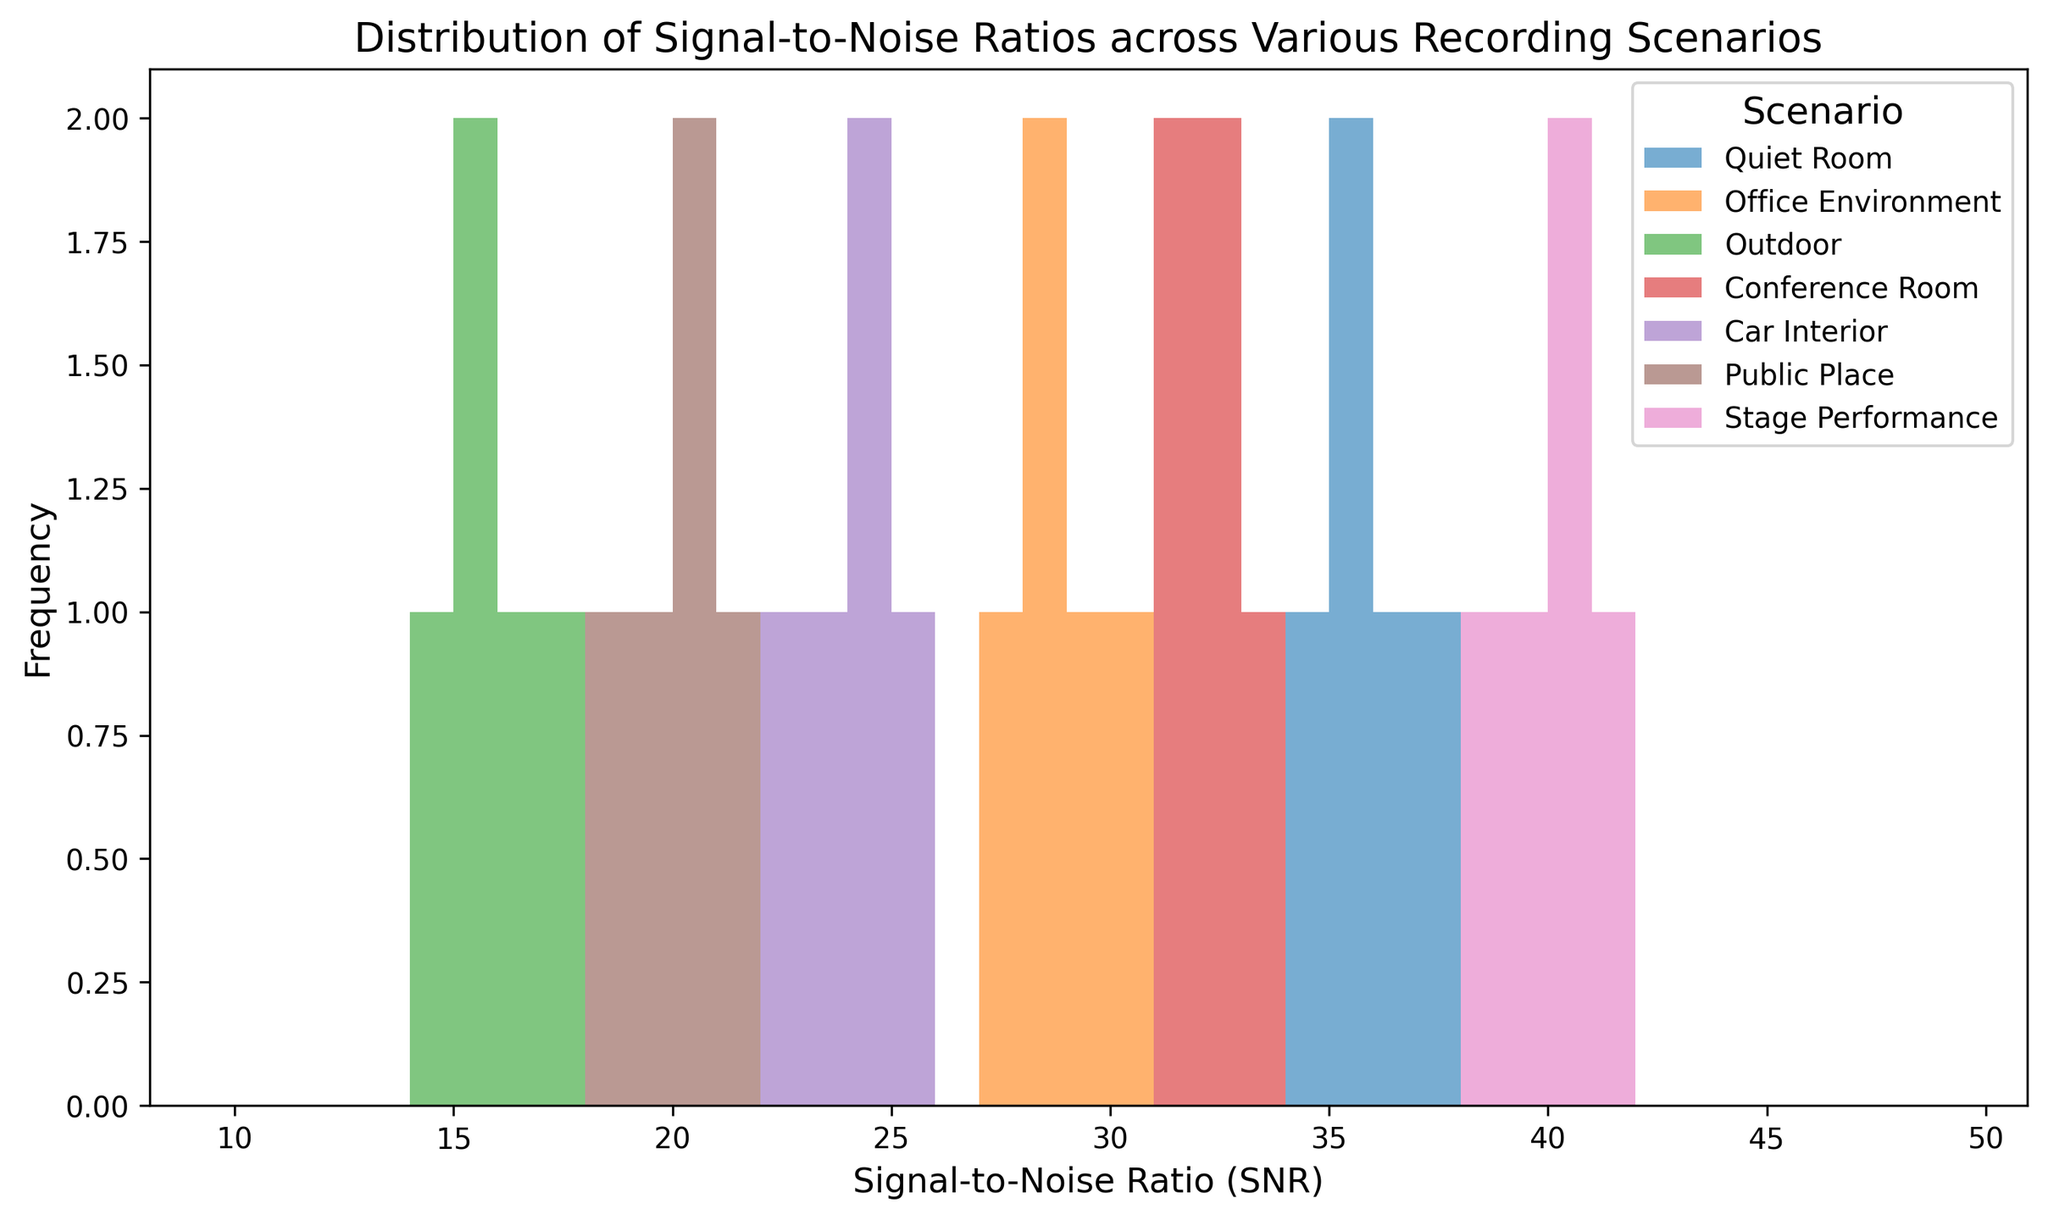What's the most frequent SNR range for stage performances? The most frequent SNR range for stage performances can be identified by locating the highest bar in the histogram's section corresponding to stage performances, which are typically shaded in pink. Look for which bin in the stage performance section has the highest count.
Answer: 40-41 Which scenario has the lowest SNR range, and what is that range? To find the scenario with the lowest SNR range, examine the bins on the far left of the histogram and identify which scenario's colors are present in this area. The lowest range corresponds to the `Outdoor` scenario, represented by bars in green.
Answer: Outdoor, 14-17 How do the SNR values for a quiet room compare to those in a conference room? To compare the SNR values, analyze the histogram sections for the quiet room (shaded in blue) and the conference room (shaded in red). Both sets of bars fall within a similar range, just over 30, but the quiet room's SNR values are generally a bit higher.
Answer: Quiet Room's SNR values are slightly higher What is the average SNR for an office environment and a car interior combined? Calculate the average SNR by summing the SNR values of both scenarios and dividing by the total number of data points. The office environment has SNRs of 28, 29, 27, 30, and 28. The car interior has SNRs of 24, 22, 23, 24, and 25. The combined sum is (28 + 29 + 27 + 30 + 28 + 24 + 22 + 23 + 24 + 25) = 260, with 10 data points in total. Therefore, the average is 260 / 10.
Answer: 26 Which scenario shows the greatest variability in SNR values? To identify the scenario with the greatest variability, observe the spread or range of the bars within each scenario's section. The wider the spread, the more variability. The `Outdoor` scenario, shaded in green, shows SNR values ranging from 14 to 17, indicating considerable variability.
Answer: Outdoor For each scenario, which has the lowest median SNR value? To determine the median SNR value for each scenario, sort the SNR values and find the middle value for each: 
Quiet Room: 34, 35, 35, 36, 37 (Median = 35)
Office Environment: 27, 28, 28, 29, 30 (Median = 28)
Outdoor: 14, 15, 15, 16, 17 (Median = 15)
Conference Room: 31, 31, 32, 32, 33 (Median = 32)
Car Interior: 22, 23, 24, 24, 25 (Median = 24)
Public Place: 18, 19, 20, 20, 21 (Median = 20)
Stage Performance: 38, 39, 40, 40, 41 (Median = 40)
The lowest median SNR value among these is 15 from the outdoor scenario.
Answer: Outdoor, 15 